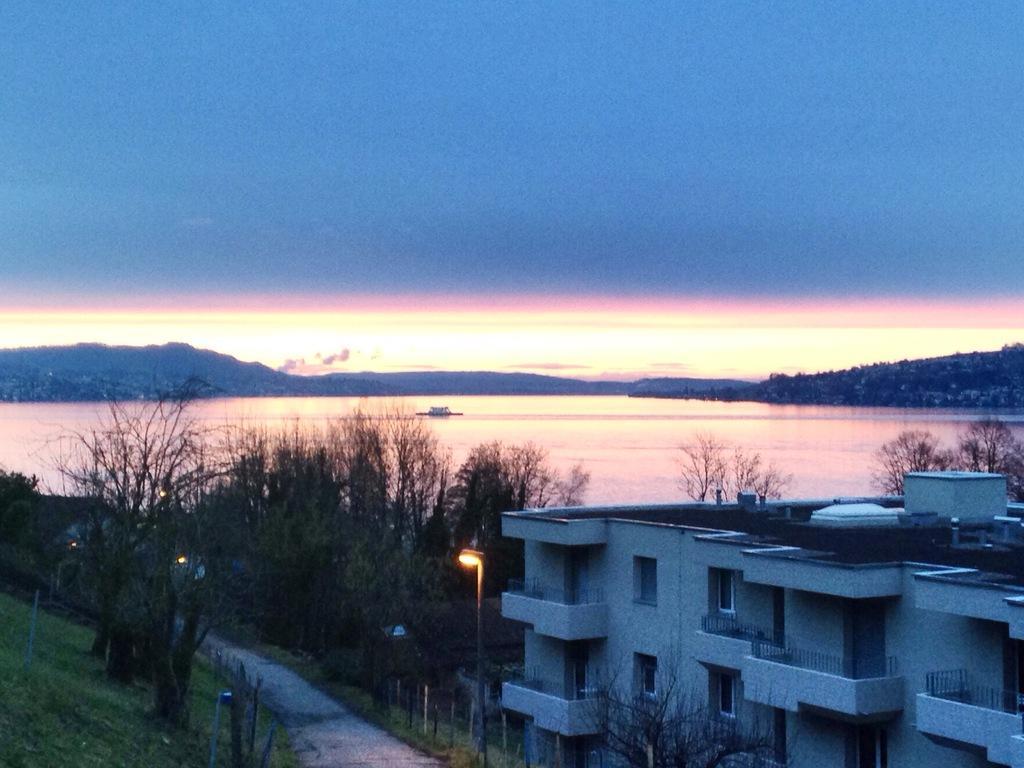Could you give a brief overview of what you see in this image? In this image there is a road in the middle. Beside the road there are trees. At the top there is sky. In the background there is water which is surrounded by the hills. On the right side bottom there is a building. In front of the building there is a light. 